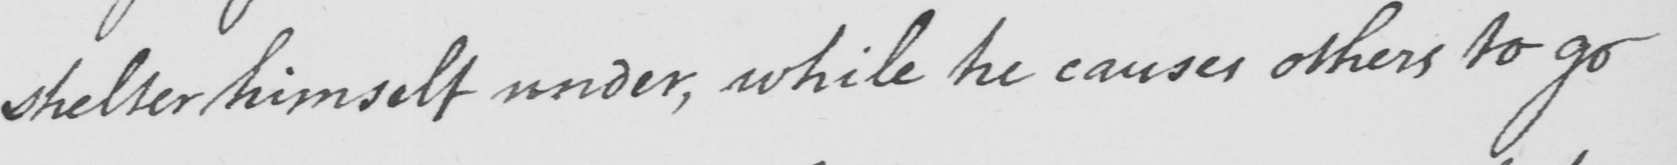Please transcribe the handwritten text in this image. shelter himself under , while he causes others to go 